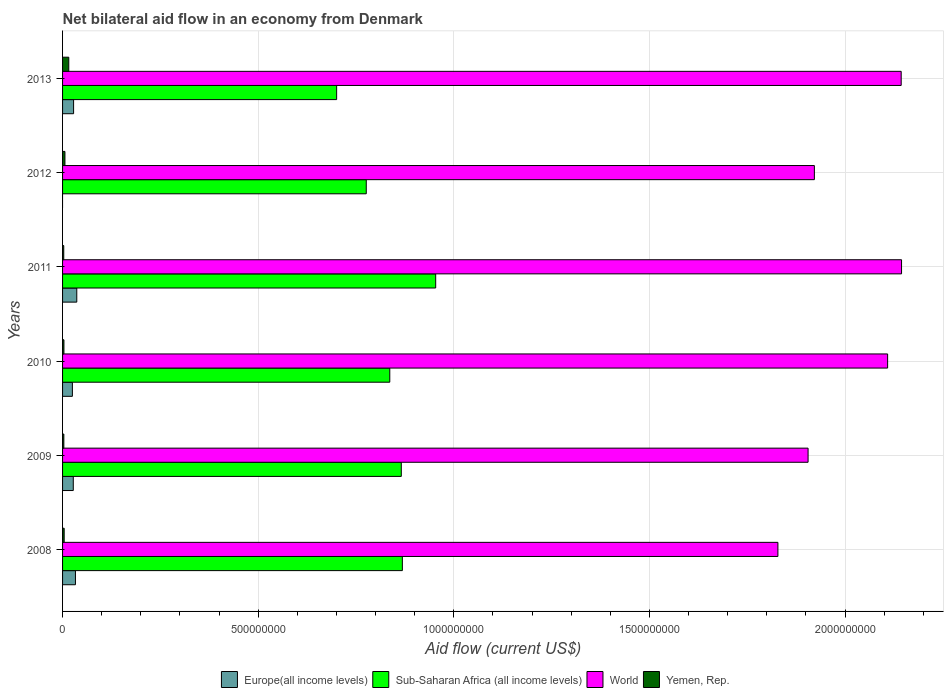How many groups of bars are there?
Keep it short and to the point. 6. Are the number of bars on each tick of the Y-axis equal?
Offer a very short reply. No. How many bars are there on the 5th tick from the bottom?
Make the answer very short. 3. What is the net bilateral aid flow in World in 2013?
Provide a short and direct response. 2.14e+09. Across all years, what is the maximum net bilateral aid flow in World?
Offer a very short reply. 2.14e+09. Across all years, what is the minimum net bilateral aid flow in Yemen, Rep.?
Make the answer very short. 3.02e+06. In which year was the net bilateral aid flow in Europe(all income levels) maximum?
Provide a succinct answer. 2011. What is the total net bilateral aid flow in Yemen, Rep. in the graph?
Your answer should be very brief. 3.58e+07. What is the difference between the net bilateral aid flow in Yemen, Rep. in 2010 and that in 2013?
Give a very brief answer. -1.24e+07. What is the difference between the net bilateral aid flow in World in 2009 and the net bilateral aid flow in Yemen, Rep. in 2011?
Offer a very short reply. 1.90e+09. What is the average net bilateral aid flow in World per year?
Offer a very short reply. 2.01e+09. In the year 2010, what is the difference between the net bilateral aid flow in Sub-Saharan Africa (all income levels) and net bilateral aid flow in Europe(all income levels)?
Offer a very short reply. 8.11e+08. What is the ratio of the net bilateral aid flow in World in 2009 to that in 2013?
Make the answer very short. 0.89. What is the difference between the highest and the second highest net bilateral aid flow in Sub-Saharan Africa (all income levels)?
Your answer should be very brief. 8.52e+07. What is the difference between the highest and the lowest net bilateral aid flow in Europe(all income levels)?
Your answer should be very brief. 3.63e+07. Is it the case that in every year, the sum of the net bilateral aid flow in World and net bilateral aid flow in Europe(all income levels) is greater than the sum of net bilateral aid flow in Sub-Saharan Africa (all income levels) and net bilateral aid flow in Yemen, Rep.?
Keep it short and to the point. Yes. How many bars are there?
Provide a short and direct response. 23. Are all the bars in the graph horizontal?
Offer a very short reply. Yes. How many years are there in the graph?
Your answer should be compact. 6. What is the difference between two consecutive major ticks on the X-axis?
Offer a very short reply. 5.00e+08. Are the values on the major ticks of X-axis written in scientific E-notation?
Offer a terse response. No. Where does the legend appear in the graph?
Offer a very short reply. Bottom center. What is the title of the graph?
Keep it short and to the point. Net bilateral aid flow in an economy from Denmark. Does "Jamaica" appear as one of the legend labels in the graph?
Your response must be concise. No. What is the Aid flow (current US$) of Europe(all income levels) in 2008?
Make the answer very short. 3.29e+07. What is the Aid flow (current US$) in Sub-Saharan Africa (all income levels) in 2008?
Offer a terse response. 8.68e+08. What is the Aid flow (current US$) in World in 2008?
Provide a short and direct response. 1.83e+09. What is the Aid flow (current US$) of Yemen, Rep. in 2008?
Give a very brief answer. 4.12e+06. What is the Aid flow (current US$) of Europe(all income levels) in 2009?
Ensure brevity in your answer.  2.74e+07. What is the Aid flow (current US$) of Sub-Saharan Africa (all income levels) in 2009?
Your response must be concise. 8.66e+08. What is the Aid flow (current US$) in World in 2009?
Your response must be concise. 1.91e+09. What is the Aid flow (current US$) of Yemen, Rep. in 2009?
Ensure brevity in your answer.  3.26e+06. What is the Aid flow (current US$) in Europe(all income levels) in 2010?
Your answer should be compact. 2.51e+07. What is the Aid flow (current US$) in Sub-Saharan Africa (all income levels) in 2010?
Your answer should be very brief. 8.36e+08. What is the Aid flow (current US$) of World in 2010?
Your response must be concise. 2.11e+09. What is the Aid flow (current US$) of Yemen, Rep. in 2010?
Offer a very short reply. 3.49e+06. What is the Aid flow (current US$) of Europe(all income levels) in 2011?
Make the answer very short. 3.63e+07. What is the Aid flow (current US$) in Sub-Saharan Africa (all income levels) in 2011?
Provide a succinct answer. 9.54e+08. What is the Aid flow (current US$) in World in 2011?
Give a very brief answer. 2.14e+09. What is the Aid flow (current US$) in Yemen, Rep. in 2011?
Ensure brevity in your answer.  3.02e+06. What is the Aid flow (current US$) of Sub-Saharan Africa (all income levels) in 2012?
Give a very brief answer. 7.76e+08. What is the Aid flow (current US$) of World in 2012?
Offer a very short reply. 1.92e+09. What is the Aid flow (current US$) in Yemen, Rep. in 2012?
Your response must be concise. 6.05e+06. What is the Aid flow (current US$) of Europe(all income levels) in 2013?
Provide a short and direct response. 2.82e+07. What is the Aid flow (current US$) of Sub-Saharan Africa (all income levels) in 2013?
Make the answer very short. 7.01e+08. What is the Aid flow (current US$) of World in 2013?
Give a very brief answer. 2.14e+09. What is the Aid flow (current US$) in Yemen, Rep. in 2013?
Keep it short and to the point. 1.59e+07. Across all years, what is the maximum Aid flow (current US$) of Europe(all income levels)?
Ensure brevity in your answer.  3.63e+07. Across all years, what is the maximum Aid flow (current US$) of Sub-Saharan Africa (all income levels)?
Ensure brevity in your answer.  9.54e+08. Across all years, what is the maximum Aid flow (current US$) in World?
Your response must be concise. 2.14e+09. Across all years, what is the maximum Aid flow (current US$) of Yemen, Rep.?
Your response must be concise. 1.59e+07. Across all years, what is the minimum Aid flow (current US$) in Europe(all income levels)?
Provide a succinct answer. 0. Across all years, what is the minimum Aid flow (current US$) in Sub-Saharan Africa (all income levels)?
Your answer should be compact. 7.01e+08. Across all years, what is the minimum Aid flow (current US$) of World?
Provide a succinct answer. 1.83e+09. Across all years, what is the minimum Aid flow (current US$) in Yemen, Rep.?
Provide a short and direct response. 3.02e+06. What is the total Aid flow (current US$) in Europe(all income levels) in the graph?
Your answer should be very brief. 1.50e+08. What is the total Aid flow (current US$) in Sub-Saharan Africa (all income levels) in the graph?
Provide a short and direct response. 5.00e+09. What is the total Aid flow (current US$) in World in the graph?
Give a very brief answer. 1.21e+1. What is the total Aid flow (current US$) of Yemen, Rep. in the graph?
Offer a terse response. 3.58e+07. What is the difference between the Aid flow (current US$) of Europe(all income levels) in 2008 and that in 2009?
Provide a short and direct response. 5.56e+06. What is the difference between the Aid flow (current US$) of Sub-Saharan Africa (all income levels) in 2008 and that in 2009?
Give a very brief answer. 2.74e+06. What is the difference between the Aid flow (current US$) of World in 2008 and that in 2009?
Your answer should be compact. -7.71e+07. What is the difference between the Aid flow (current US$) of Yemen, Rep. in 2008 and that in 2009?
Give a very brief answer. 8.60e+05. What is the difference between the Aid flow (current US$) of Europe(all income levels) in 2008 and that in 2010?
Keep it short and to the point. 7.83e+06. What is the difference between the Aid flow (current US$) of Sub-Saharan Africa (all income levels) in 2008 and that in 2010?
Provide a short and direct response. 3.21e+07. What is the difference between the Aid flow (current US$) in World in 2008 and that in 2010?
Provide a short and direct response. -2.80e+08. What is the difference between the Aid flow (current US$) in Yemen, Rep. in 2008 and that in 2010?
Ensure brevity in your answer.  6.30e+05. What is the difference between the Aid flow (current US$) of Europe(all income levels) in 2008 and that in 2011?
Offer a very short reply. -3.41e+06. What is the difference between the Aid flow (current US$) of Sub-Saharan Africa (all income levels) in 2008 and that in 2011?
Offer a very short reply. -8.52e+07. What is the difference between the Aid flow (current US$) of World in 2008 and that in 2011?
Your answer should be compact. -3.16e+08. What is the difference between the Aid flow (current US$) of Yemen, Rep. in 2008 and that in 2011?
Provide a succinct answer. 1.10e+06. What is the difference between the Aid flow (current US$) of Sub-Saharan Africa (all income levels) in 2008 and that in 2012?
Give a very brief answer. 9.23e+07. What is the difference between the Aid flow (current US$) of World in 2008 and that in 2012?
Your response must be concise. -9.32e+07. What is the difference between the Aid flow (current US$) of Yemen, Rep. in 2008 and that in 2012?
Your answer should be compact. -1.93e+06. What is the difference between the Aid flow (current US$) in Europe(all income levels) in 2008 and that in 2013?
Make the answer very short. 4.76e+06. What is the difference between the Aid flow (current US$) in Sub-Saharan Africa (all income levels) in 2008 and that in 2013?
Provide a short and direct response. 1.68e+08. What is the difference between the Aid flow (current US$) of World in 2008 and that in 2013?
Ensure brevity in your answer.  -3.15e+08. What is the difference between the Aid flow (current US$) in Yemen, Rep. in 2008 and that in 2013?
Make the answer very short. -1.18e+07. What is the difference between the Aid flow (current US$) of Europe(all income levels) in 2009 and that in 2010?
Your response must be concise. 2.27e+06. What is the difference between the Aid flow (current US$) in Sub-Saharan Africa (all income levels) in 2009 and that in 2010?
Provide a succinct answer. 2.94e+07. What is the difference between the Aid flow (current US$) of World in 2009 and that in 2010?
Ensure brevity in your answer.  -2.03e+08. What is the difference between the Aid flow (current US$) in Europe(all income levels) in 2009 and that in 2011?
Provide a short and direct response. -8.97e+06. What is the difference between the Aid flow (current US$) of Sub-Saharan Africa (all income levels) in 2009 and that in 2011?
Your answer should be very brief. -8.79e+07. What is the difference between the Aid flow (current US$) in World in 2009 and that in 2011?
Give a very brief answer. -2.39e+08. What is the difference between the Aid flow (current US$) in Yemen, Rep. in 2009 and that in 2011?
Offer a terse response. 2.40e+05. What is the difference between the Aid flow (current US$) of Sub-Saharan Africa (all income levels) in 2009 and that in 2012?
Offer a terse response. 8.95e+07. What is the difference between the Aid flow (current US$) of World in 2009 and that in 2012?
Ensure brevity in your answer.  -1.61e+07. What is the difference between the Aid flow (current US$) in Yemen, Rep. in 2009 and that in 2012?
Ensure brevity in your answer.  -2.79e+06. What is the difference between the Aid flow (current US$) of Europe(all income levels) in 2009 and that in 2013?
Your response must be concise. -8.00e+05. What is the difference between the Aid flow (current US$) of Sub-Saharan Africa (all income levels) in 2009 and that in 2013?
Your response must be concise. 1.65e+08. What is the difference between the Aid flow (current US$) in World in 2009 and that in 2013?
Your answer should be compact. -2.38e+08. What is the difference between the Aid flow (current US$) of Yemen, Rep. in 2009 and that in 2013?
Offer a very short reply. -1.26e+07. What is the difference between the Aid flow (current US$) of Europe(all income levels) in 2010 and that in 2011?
Your answer should be very brief. -1.12e+07. What is the difference between the Aid flow (current US$) in Sub-Saharan Africa (all income levels) in 2010 and that in 2011?
Ensure brevity in your answer.  -1.17e+08. What is the difference between the Aid flow (current US$) of World in 2010 and that in 2011?
Your answer should be very brief. -3.56e+07. What is the difference between the Aid flow (current US$) in Sub-Saharan Africa (all income levels) in 2010 and that in 2012?
Offer a very short reply. 6.01e+07. What is the difference between the Aid flow (current US$) of World in 2010 and that in 2012?
Offer a very short reply. 1.87e+08. What is the difference between the Aid flow (current US$) in Yemen, Rep. in 2010 and that in 2012?
Offer a very short reply. -2.56e+06. What is the difference between the Aid flow (current US$) of Europe(all income levels) in 2010 and that in 2013?
Ensure brevity in your answer.  -3.07e+06. What is the difference between the Aid flow (current US$) in Sub-Saharan Africa (all income levels) in 2010 and that in 2013?
Make the answer very short. 1.36e+08. What is the difference between the Aid flow (current US$) of World in 2010 and that in 2013?
Your response must be concise. -3.47e+07. What is the difference between the Aid flow (current US$) in Yemen, Rep. in 2010 and that in 2013?
Offer a terse response. -1.24e+07. What is the difference between the Aid flow (current US$) in Sub-Saharan Africa (all income levels) in 2011 and that in 2012?
Ensure brevity in your answer.  1.77e+08. What is the difference between the Aid flow (current US$) of World in 2011 and that in 2012?
Give a very brief answer. 2.23e+08. What is the difference between the Aid flow (current US$) of Yemen, Rep. in 2011 and that in 2012?
Your answer should be compact. -3.03e+06. What is the difference between the Aid flow (current US$) of Europe(all income levels) in 2011 and that in 2013?
Ensure brevity in your answer.  8.17e+06. What is the difference between the Aid flow (current US$) of Sub-Saharan Africa (all income levels) in 2011 and that in 2013?
Offer a very short reply. 2.53e+08. What is the difference between the Aid flow (current US$) of World in 2011 and that in 2013?
Make the answer very short. 8.90e+05. What is the difference between the Aid flow (current US$) in Yemen, Rep. in 2011 and that in 2013?
Keep it short and to the point. -1.29e+07. What is the difference between the Aid flow (current US$) in Sub-Saharan Africa (all income levels) in 2012 and that in 2013?
Make the answer very short. 7.57e+07. What is the difference between the Aid flow (current US$) of World in 2012 and that in 2013?
Your answer should be compact. -2.22e+08. What is the difference between the Aid flow (current US$) in Yemen, Rep. in 2012 and that in 2013?
Keep it short and to the point. -9.83e+06. What is the difference between the Aid flow (current US$) of Europe(all income levels) in 2008 and the Aid flow (current US$) of Sub-Saharan Africa (all income levels) in 2009?
Your response must be concise. -8.33e+08. What is the difference between the Aid flow (current US$) of Europe(all income levels) in 2008 and the Aid flow (current US$) of World in 2009?
Provide a short and direct response. -1.87e+09. What is the difference between the Aid flow (current US$) of Europe(all income levels) in 2008 and the Aid flow (current US$) of Yemen, Rep. in 2009?
Provide a succinct answer. 2.97e+07. What is the difference between the Aid flow (current US$) in Sub-Saharan Africa (all income levels) in 2008 and the Aid flow (current US$) in World in 2009?
Your response must be concise. -1.04e+09. What is the difference between the Aid flow (current US$) of Sub-Saharan Africa (all income levels) in 2008 and the Aid flow (current US$) of Yemen, Rep. in 2009?
Your answer should be compact. 8.65e+08. What is the difference between the Aid flow (current US$) in World in 2008 and the Aid flow (current US$) in Yemen, Rep. in 2009?
Your answer should be very brief. 1.83e+09. What is the difference between the Aid flow (current US$) in Europe(all income levels) in 2008 and the Aid flow (current US$) in Sub-Saharan Africa (all income levels) in 2010?
Offer a very short reply. -8.03e+08. What is the difference between the Aid flow (current US$) of Europe(all income levels) in 2008 and the Aid flow (current US$) of World in 2010?
Keep it short and to the point. -2.08e+09. What is the difference between the Aid flow (current US$) of Europe(all income levels) in 2008 and the Aid flow (current US$) of Yemen, Rep. in 2010?
Provide a succinct answer. 2.94e+07. What is the difference between the Aid flow (current US$) of Sub-Saharan Africa (all income levels) in 2008 and the Aid flow (current US$) of World in 2010?
Keep it short and to the point. -1.24e+09. What is the difference between the Aid flow (current US$) of Sub-Saharan Africa (all income levels) in 2008 and the Aid flow (current US$) of Yemen, Rep. in 2010?
Offer a terse response. 8.65e+08. What is the difference between the Aid flow (current US$) in World in 2008 and the Aid flow (current US$) in Yemen, Rep. in 2010?
Offer a terse response. 1.82e+09. What is the difference between the Aid flow (current US$) in Europe(all income levels) in 2008 and the Aid flow (current US$) in Sub-Saharan Africa (all income levels) in 2011?
Keep it short and to the point. -9.21e+08. What is the difference between the Aid flow (current US$) in Europe(all income levels) in 2008 and the Aid flow (current US$) in World in 2011?
Provide a succinct answer. -2.11e+09. What is the difference between the Aid flow (current US$) of Europe(all income levels) in 2008 and the Aid flow (current US$) of Yemen, Rep. in 2011?
Your response must be concise. 2.99e+07. What is the difference between the Aid flow (current US$) in Sub-Saharan Africa (all income levels) in 2008 and the Aid flow (current US$) in World in 2011?
Provide a succinct answer. -1.28e+09. What is the difference between the Aid flow (current US$) in Sub-Saharan Africa (all income levels) in 2008 and the Aid flow (current US$) in Yemen, Rep. in 2011?
Offer a very short reply. 8.65e+08. What is the difference between the Aid flow (current US$) in World in 2008 and the Aid flow (current US$) in Yemen, Rep. in 2011?
Give a very brief answer. 1.83e+09. What is the difference between the Aid flow (current US$) in Europe(all income levels) in 2008 and the Aid flow (current US$) in Sub-Saharan Africa (all income levels) in 2012?
Give a very brief answer. -7.43e+08. What is the difference between the Aid flow (current US$) of Europe(all income levels) in 2008 and the Aid flow (current US$) of World in 2012?
Offer a terse response. -1.89e+09. What is the difference between the Aid flow (current US$) of Europe(all income levels) in 2008 and the Aid flow (current US$) of Yemen, Rep. in 2012?
Offer a very short reply. 2.69e+07. What is the difference between the Aid flow (current US$) of Sub-Saharan Africa (all income levels) in 2008 and the Aid flow (current US$) of World in 2012?
Your answer should be very brief. -1.05e+09. What is the difference between the Aid flow (current US$) in Sub-Saharan Africa (all income levels) in 2008 and the Aid flow (current US$) in Yemen, Rep. in 2012?
Make the answer very short. 8.62e+08. What is the difference between the Aid flow (current US$) of World in 2008 and the Aid flow (current US$) of Yemen, Rep. in 2012?
Offer a very short reply. 1.82e+09. What is the difference between the Aid flow (current US$) in Europe(all income levels) in 2008 and the Aid flow (current US$) in Sub-Saharan Africa (all income levels) in 2013?
Your response must be concise. -6.68e+08. What is the difference between the Aid flow (current US$) of Europe(all income levels) in 2008 and the Aid flow (current US$) of World in 2013?
Your response must be concise. -2.11e+09. What is the difference between the Aid flow (current US$) in Europe(all income levels) in 2008 and the Aid flow (current US$) in Yemen, Rep. in 2013?
Make the answer very short. 1.70e+07. What is the difference between the Aid flow (current US$) in Sub-Saharan Africa (all income levels) in 2008 and the Aid flow (current US$) in World in 2013?
Provide a short and direct response. -1.27e+09. What is the difference between the Aid flow (current US$) of Sub-Saharan Africa (all income levels) in 2008 and the Aid flow (current US$) of Yemen, Rep. in 2013?
Your response must be concise. 8.53e+08. What is the difference between the Aid flow (current US$) of World in 2008 and the Aid flow (current US$) of Yemen, Rep. in 2013?
Provide a short and direct response. 1.81e+09. What is the difference between the Aid flow (current US$) in Europe(all income levels) in 2009 and the Aid flow (current US$) in Sub-Saharan Africa (all income levels) in 2010?
Offer a very short reply. -8.09e+08. What is the difference between the Aid flow (current US$) in Europe(all income levels) in 2009 and the Aid flow (current US$) in World in 2010?
Your response must be concise. -2.08e+09. What is the difference between the Aid flow (current US$) of Europe(all income levels) in 2009 and the Aid flow (current US$) of Yemen, Rep. in 2010?
Your answer should be very brief. 2.39e+07. What is the difference between the Aid flow (current US$) of Sub-Saharan Africa (all income levels) in 2009 and the Aid flow (current US$) of World in 2010?
Your answer should be compact. -1.24e+09. What is the difference between the Aid flow (current US$) in Sub-Saharan Africa (all income levels) in 2009 and the Aid flow (current US$) in Yemen, Rep. in 2010?
Provide a short and direct response. 8.62e+08. What is the difference between the Aid flow (current US$) of World in 2009 and the Aid flow (current US$) of Yemen, Rep. in 2010?
Ensure brevity in your answer.  1.90e+09. What is the difference between the Aid flow (current US$) in Europe(all income levels) in 2009 and the Aid flow (current US$) in Sub-Saharan Africa (all income levels) in 2011?
Ensure brevity in your answer.  -9.26e+08. What is the difference between the Aid flow (current US$) of Europe(all income levels) in 2009 and the Aid flow (current US$) of World in 2011?
Ensure brevity in your answer.  -2.12e+09. What is the difference between the Aid flow (current US$) of Europe(all income levels) in 2009 and the Aid flow (current US$) of Yemen, Rep. in 2011?
Your answer should be very brief. 2.44e+07. What is the difference between the Aid flow (current US$) in Sub-Saharan Africa (all income levels) in 2009 and the Aid flow (current US$) in World in 2011?
Keep it short and to the point. -1.28e+09. What is the difference between the Aid flow (current US$) in Sub-Saharan Africa (all income levels) in 2009 and the Aid flow (current US$) in Yemen, Rep. in 2011?
Your response must be concise. 8.63e+08. What is the difference between the Aid flow (current US$) in World in 2009 and the Aid flow (current US$) in Yemen, Rep. in 2011?
Provide a short and direct response. 1.90e+09. What is the difference between the Aid flow (current US$) of Europe(all income levels) in 2009 and the Aid flow (current US$) of Sub-Saharan Africa (all income levels) in 2012?
Your answer should be compact. -7.49e+08. What is the difference between the Aid flow (current US$) of Europe(all income levels) in 2009 and the Aid flow (current US$) of World in 2012?
Ensure brevity in your answer.  -1.89e+09. What is the difference between the Aid flow (current US$) of Europe(all income levels) in 2009 and the Aid flow (current US$) of Yemen, Rep. in 2012?
Your answer should be very brief. 2.13e+07. What is the difference between the Aid flow (current US$) in Sub-Saharan Africa (all income levels) in 2009 and the Aid flow (current US$) in World in 2012?
Ensure brevity in your answer.  -1.06e+09. What is the difference between the Aid flow (current US$) of Sub-Saharan Africa (all income levels) in 2009 and the Aid flow (current US$) of Yemen, Rep. in 2012?
Offer a very short reply. 8.60e+08. What is the difference between the Aid flow (current US$) of World in 2009 and the Aid flow (current US$) of Yemen, Rep. in 2012?
Ensure brevity in your answer.  1.90e+09. What is the difference between the Aid flow (current US$) in Europe(all income levels) in 2009 and the Aid flow (current US$) in Sub-Saharan Africa (all income levels) in 2013?
Offer a very short reply. -6.73e+08. What is the difference between the Aid flow (current US$) of Europe(all income levels) in 2009 and the Aid flow (current US$) of World in 2013?
Make the answer very short. -2.12e+09. What is the difference between the Aid flow (current US$) of Europe(all income levels) in 2009 and the Aid flow (current US$) of Yemen, Rep. in 2013?
Offer a very short reply. 1.15e+07. What is the difference between the Aid flow (current US$) of Sub-Saharan Africa (all income levels) in 2009 and the Aid flow (current US$) of World in 2013?
Offer a terse response. -1.28e+09. What is the difference between the Aid flow (current US$) of Sub-Saharan Africa (all income levels) in 2009 and the Aid flow (current US$) of Yemen, Rep. in 2013?
Your answer should be compact. 8.50e+08. What is the difference between the Aid flow (current US$) in World in 2009 and the Aid flow (current US$) in Yemen, Rep. in 2013?
Offer a very short reply. 1.89e+09. What is the difference between the Aid flow (current US$) of Europe(all income levels) in 2010 and the Aid flow (current US$) of Sub-Saharan Africa (all income levels) in 2011?
Your response must be concise. -9.29e+08. What is the difference between the Aid flow (current US$) of Europe(all income levels) in 2010 and the Aid flow (current US$) of World in 2011?
Make the answer very short. -2.12e+09. What is the difference between the Aid flow (current US$) in Europe(all income levels) in 2010 and the Aid flow (current US$) in Yemen, Rep. in 2011?
Make the answer very short. 2.21e+07. What is the difference between the Aid flow (current US$) of Sub-Saharan Africa (all income levels) in 2010 and the Aid flow (current US$) of World in 2011?
Your response must be concise. -1.31e+09. What is the difference between the Aid flow (current US$) of Sub-Saharan Africa (all income levels) in 2010 and the Aid flow (current US$) of Yemen, Rep. in 2011?
Give a very brief answer. 8.33e+08. What is the difference between the Aid flow (current US$) of World in 2010 and the Aid flow (current US$) of Yemen, Rep. in 2011?
Your answer should be compact. 2.11e+09. What is the difference between the Aid flow (current US$) in Europe(all income levels) in 2010 and the Aid flow (current US$) in Sub-Saharan Africa (all income levels) in 2012?
Provide a short and direct response. -7.51e+08. What is the difference between the Aid flow (current US$) in Europe(all income levels) in 2010 and the Aid flow (current US$) in World in 2012?
Give a very brief answer. -1.90e+09. What is the difference between the Aid flow (current US$) of Europe(all income levels) in 2010 and the Aid flow (current US$) of Yemen, Rep. in 2012?
Ensure brevity in your answer.  1.90e+07. What is the difference between the Aid flow (current US$) in Sub-Saharan Africa (all income levels) in 2010 and the Aid flow (current US$) in World in 2012?
Ensure brevity in your answer.  -1.09e+09. What is the difference between the Aid flow (current US$) in Sub-Saharan Africa (all income levels) in 2010 and the Aid flow (current US$) in Yemen, Rep. in 2012?
Keep it short and to the point. 8.30e+08. What is the difference between the Aid flow (current US$) in World in 2010 and the Aid flow (current US$) in Yemen, Rep. in 2012?
Make the answer very short. 2.10e+09. What is the difference between the Aid flow (current US$) in Europe(all income levels) in 2010 and the Aid flow (current US$) in Sub-Saharan Africa (all income levels) in 2013?
Ensure brevity in your answer.  -6.75e+08. What is the difference between the Aid flow (current US$) in Europe(all income levels) in 2010 and the Aid flow (current US$) in World in 2013?
Your answer should be compact. -2.12e+09. What is the difference between the Aid flow (current US$) of Europe(all income levels) in 2010 and the Aid flow (current US$) of Yemen, Rep. in 2013?
Keep it short and to the point. 9.22e+06. What is the difference between the Aid flow (current US$) in Sub-Saharan Africa (all income levels) in 2010 and the Aid flow (current US$) in World in 2013?
Ensure brevity in your answer.  -1.31e+09. What is the difference between the Aid flow (current US$) of Sub-Saharan Africa (all income levels) in 2010 and the Aid flow (current US$) of Yemen, Rep. in 2013?
Your answer should be very brief. 8.20e+08. What is the difference between the Aid flow (current US$) in World in 2010 and the Aid flow (current US$) in Yemen, Rep. in 2013?
Make the answer very short. 2.09e+09. What is the difference between the Aid flow (current US$) in Europe(all income levels) in 2011 and the Aid flow (current US$) in Sub-Saharan Africa (all income levels) in 2012?
Give a very brief answer. -7.40e+08. What is the difference between the Aid flow (current US$) of Europe(all income levels) in 2011 and the Aid flow (current US$) of World in 2012?
Provide a succinct answer. -1.89e+09. What is the difference between the Aid flow (current US$) in Europe(all income levels) in 2011 and the Aid flow (current US$) in Yemen, Rep. in 2012?
Your response must be concise. 3.03e+07. What is the difference between the Aid flow (current US$) of Sub-Saharan Africa (all income levels) in 2011 and the Aid flow (current US$) of World in 2012?
Your answer should be very brief. -9.68e+08. What is the difference between the Aid flow (current US$) in Sub-Saharan Africa (all income levels) in 2011 and the Aid flow (current US$) in Yemen, Rep. in 2012?
Keep it short and to the point. 9.48e+08. What is the difference between the Aid flow (current US$) in World in 2011 and the Aid flow (current US$) in Yemen, Rep. in 2012?
Offer a very short reply. 2.14e+09. What is the difference between the Aid flow (current US$) of Europe(all income levels) in 2011 and the Aid flow (current US$) of Sub-Saharan Africa (all income levels) in 2013?
Your answer should be very brief. -6.64e+08. What is the difference between the Aid flow (current US$) in Europe(all income levels) in 2011 and the Aid flow (current US$) in World in 2013?
Provide a short and direct response. -2.11e+09. What is the difference between the Aid flow (current US$) of Europe(all income levels) in 2011 and the Aid flow (current US$) of Yemen, Rep. in 2013?
Give a very brief answer. 2.05e+07. What is the difference between the Aid flow (current US$) of Sub-Saharan Africa (all income levels) in 2011 and the Aid flow (current US$) of World in 2013?
Ensure brevity in your answer.  -1.19e+09. What is the difference between the Aid flow (current US$) of Sub-Saharan Africa (all income levels) in 2011 and the Aid flow (current US$) of Yemen, Rep. in 2013?
Your response must be concise. 9.38e+08. What is the difference between the Aid flow (current US$) in World in 2011 and the Aid flow (current US$) in Yemen, Rep. in 2013?
Offer a terse response. 2.13e+09. What is the difference between the Aid flow (current US$) in Sub-Saharan Africa (all income levels) in 2012 and the Aid flow (current US$) in World in 2013?
Your answer should be very brief. -1.37e+09. What is the difference between the Aid flow (current US$) of Sub-Saharan Africa (all income levels) in 2012 and the Aid flow (current US$) of Yemen, Rep. in 2013?
Offer a terse response. 7.60e+08. What is the difference between the Aid flow (current US$) in World in 2012 and the Aid flow (current US$) in Yemen, Rep. in 2013?
Keep it short and to the point. 1.91e+09. What is the average Aid flow (current US$) of Europe(all income levels) per year?
Your answer should be compact. 2.50e+07. What is the average Aid flow (current US$) of Sub-Saharan Africa (all income levels) per year?
Your response must be concise. 8.33e+08. What is the average Aid flow (current US$) in World per year?
Ensure brevity in your answer.  2.01e+09. What is the average Aid flow (current US$) in Yemen, Rep. per year?
Give a very brief answer. 5.97e+06. In the year 2008, what is the difference between the Aid flow (current US$) of Europe(all income levels) and Aid flow (current US$) of Sub-Saharan Africa (all income levels)?
Give a very brief answer. -8.36e+08. In the year 2008, what is the difference between the Aid flow (current US$) in Europe(all income levels) and Aid flow (current US$) in World?
Provide a short and direct response. -1.80e+09. In the year 2008, what is the difference between the Aid flow (current US$) in Europe(all income levels) and Aid flow (current US$) in Yemen, Rep.?
Ensure brevity in your answer.  2.88e+07. In the year 2008, what is the difference between the Aid flow (current US$) of Sub-Saharan Africa (all income levels) and Aid flow (current US$) of World?
Provide a succinct answer. -9.60e+08. In the year 2008, what is the difference between the Aid flow (current US$) in Sub-Saharan Africa (all income levels) and Aid flow (current US$) in Yemen, Rep.?
Make the answer very short. 8.64e+08. In the year 2008, what is the difference between the Aid flow (current US$) in World and Aid flow (current US$) in Yemen, Rep.?
Offer a very short reply. 1.82e+09. In the year 2009, what is the difference between the Aid flow (current US$) of Europe(all income levels) and Aid flow (current US$) of Sub-Saharan Africa (all income levels)?
Offer a very short reply. -8.38e+08. In the year 2009, what is the difference between the Aid flow (current US$) of Europe(all income levels) and Aid flow (current US$) of World?
Ensure brevity in your answer.  -1.88e+09. In the year 2009, what is the difference between the Aid flow (current US$) of Europe(all income levels) and Aid flow (current US$) of Yemen, Rep.?
Provide a succinct answer. 2.41e+07. In the year 2009, what is the difference between the Aid flow (current US$) in Sub-Saharan Africa (all income levels) and Aid flow (current US$) in World?
Offer a very short reply. -1.04e+09. In the year 2009, what is the difference between the Aid flow (current US$) of Sub-Saharan Africa (all income levels) and Aid flow (current US$) of Yemen, Rep.?
Ensure brevity in your answer.  8.62e+08. In the year 2009, what is the difference between the Aid flow (current US$) in World and Aid flow (current US$) in Yemen, Rep.?
Keep it short and to the point. 1.90e+09. In the year 2010, what is the difference between the Aid flow (current US$) of Europe(all income levels) and Aid flow (current US$) of Sub-Saharan Africa (all income levels)?
Give a very brief answer. -8.11e+08. In the year 2010, what is the difference between the Aid flow (current US$) of Europe(all income levels) and Aid flow (current US$) of World?
Your answer should be compact. -2.08e+09. In the year 2010, what is the difference between the Aid flow (current US$) in Europe(all income levels) and Aid flow (current US$) in Yemen, Rep.?
Ensure brevity in your answer.  2.16e+07. In the year 2010, what is the difference between the Aid flow (current US$) in Sub-Saharan Africa (all income levels) and Aid flow (current US$) in World?
Ensure brevity in your answer.  -1.27e+09. In the year 2010, what is the difference between the Aid flow (current US$) in Sub-Saharan Africa (all income levels) and Aid flow (current US$) in Yemen, Rep.?
Your response must be concise. 8.33e+08. In the year 2010, what is the difference between the Aid flow (current US$) of World and Aid flow (current US$) of Yemen, Rep.?
Make the answer very short. 2.11e+09. In the year 2011, what is the difference between the Aid flow (current US$) in Europe(all income levels) and Aid flow (current US$) in Sub-Saharan Africa (all income levels)?
Offer a terse response. -9.17e+08. In the year 2011, what is the difference between the Aid flow (current US$) of Europe(all income levels) and Aid flow (current US$) of World?
Ensure brevity in your answer.  -2.11e+09. In the year 2011, what is the difference between the Aid flow (current US$) of Europe(all income levels) and Aid flow (current US$) of Yemen, Rep.?
Your answer should be very brief. 3.33e+07. In the year 2011, what is the difference between the Aid flow (current US$) in Sub-Saharan Africa (all income levels) and Aid flow (current US$) in World?
Provide a short and direct response. -1.19e+09. In the year 2011, what is the difference between the Aid flow (current US$) of Sub-Saharan Africa (all income levels) and Aid flow (current US$) of Yemen, Rep.?
Your answer should be very brief. 9.51e+08. In the year 2011, what is the difference between the Aid flow (current US$) of World and Aid flow (current US$) of Yemen, Rep.?
Offer a very short reply. 2.14e+09. In the year 2012, what is the difference between the Aid flow (current US$) of Sub-Saharan Africa (all income levels) and Aid flow (current US$) of World?
Offer a very short reply. -1.15e+09. In the year 2012, what is the difference between the Aid flow (current US$) of Sub-Saharan Africa (all income levels) and Aid flow (current US$) of Yemen, Rep.?
Keep it short and to the point. 7.70e+08. In the year 2012, what is the difference between the Aid flow (current US$) in World and Aid flow (current US$) in Yemen, Rep.?
Your answer should be very brief. 1.92e+09. In the year 2013, what is the difference between the Aid flow (current US$) in Europe(all income levels) and Aid flow (current US$) in Sub-Saharan Africa (all income levels)?
Provide a succinct answer. -6.72e+08. In the year 2013, what is the difference between the Aid flow (current US$) of Europe(all income levels) and Aid flow (current US$) of World?
Your answer should be compact. -2.12e+09. In the year 2013, what is the difference between the Aid flow (current US$) in Europe(all income levels) and Aid flow (current US$) in Yemen, Rep.?
Your answer should be compact. 1.23e+07. In the year 2013, what is the difference between the Aid flow (current US$) of Sub-Saharan Africa (all income levels) and Aid flow (current US$) of World?
Offer a very short reply. -1.44e+09. In the year 2013, what is the difference between the Aid flow (current US$) in Sub-Saharan Africa (all income levels) and Aid flow (current US$) in Yemen, Rep.?
Your answer should be very brief. 6.85e+08. In the year 2013, what is the difference between the Aid flow (current US$) of World and Aid flow (current US$) of Yemen, Rep.?
Give a very brief answer. 2.13e+09. What is the ratio of the Aid flow (current US$) of Europe(all income levels) in 2008 to that in 2009?
Provide a short and direct response. 1.2. What is the ratio of the Aid flow (current US$) in Sub-Saharan Africa (all income levels) in 2008 to that in 2009?
Make the answer very short. 1. What is the ratio of the Aid flow (current US$) of World in 2008 to that in 2009?
Offer a terse response. 0.96. What is the ratio of the Aid flow (current US$) of Yemen, Rep. in 2008 to that in 2009?
Offer a terse response. 1.26. What is the ratio of the Aid flow (current US$) in Europe(all income levels) in 2008 to that in 2010?
Your response must be concise. 1.31. What is the ratio of the Aid flow (current US$) in Sub-Saharan Africa (all income levels) in 2008 to that in 2010?
Offer a very short reply. 1.04. What is the ratio of the Aid flow (current US$) in World in 2008 to that in 2010?
Your answer should be compact. 0.87. What is the ratio of the Aid flow (current US$) of Yemen, Rep. in 2008 to that in 2010?
Provide a succinct answer. 1.18. What is the ratio of the Aid flow (current US$) of Europe(all income levels) in 2008 to that in 2011?
Ensure brevity in your answer.  0.91. What is the ratio of the Aid flow (current US$) of Sub-Saharan Africa (all income levels) in 2008 to that in 2011?
Your answer should be very brief. 0.91. What is the ratio of the Aid flow (current US$) of World in 2008 to that in 2011?
Your response must be concise. 0.85. What is the ratio of the Aid flow (current US$) of Yemen, Rep. in 2008 to that in 2011?
Your answer should be compact. 1.36. What is the ratio of the Aid flow (current US$) of Sub-Saharan Africa (all income levels) in 2008 to that in 2012?
Give a very brief answer. 1.12. What is the ratio of the Aid flow (current US$) of World in 2008 to that in 2012?
Your response must be concise. 0.95. What is the ratio of the Aid flow (current US$) of Yemen, Rep. in 2008 to that in 2012?
Your answer should be compact. 0.68. What is the ratio of the Aid flow (current US$) of Europe(all income levels) in 2008 to that in 2013?
Your answer should be compact. 1.17. What is the ratio of the Aid flow (current US$) in Sub-Saharan Africa (all income levels) in 2008 to that in 2013?
Give a very brief answer. 1.24. What is the ratio of the Aid flow (current US$) in World in 2008 to that in 2013?
Offer a terse response. 0.85. What is the ratio of the Aid flow (current US$) in Yemen, Rep. in 2008 to that in 2013?
Your answer should be very brief. 0.26. What is the ratio of the Aid flow (current US$) in Europe(all income levels) in 2009 to that in 2010?
Offer a terse response. 1.09. What is the ratio of the Aid flow (current US$) of Sub-Saharan Africa (all income levels) in 2009 to that in 2010?
Ensure brevity in your answer.  1.04. What is the ratio of the Aid flow (current US$) in World in 2009 to that in 2010?
Give a very brief answer. 0.9. What is the ratio of the Aid flow (current US$) of Yemen, Rep. in 2009 to that in 2010?
Offer a terse response. 0.93. What is the ratio of the Aid flow (current US$) in Europe(all income levels) in 2009 to that in 2011?
Ensure brevity in your answer.  0.75. What is the ratio of the Aid flow (current US$) in Sub-Saharan Africa (all income levels) in 2009 to that in 2011?
Your response must be concise. 0.91. What is the ratio of the Aid flow (current US$) in World in 2009 to that in 2011?
Ensure brevity in your answer.  0.89. What is the ratio of the Aid flow (current US$) of Yemen, Rep. in 2009 to that in 2011?
Offer a terse response. 1.08. What is the ratio of the Aid flow (current US$) of Sub-Saharan Africa (all income levels) in 2009 to that in 2012?
Make the answer very short. 1.12. What is the ratio of the Aid flow (current US$) of World in 2009 to that in 2012?
Make the answer very short. 0.99. What is the ratio of the Aid flow (current US$) of Yemen, Rep. in 2009 to that in 2012?
Your answer should be compact. 0.54. What is the ratio of the Aid flow (current US$) in Europe(all income levels) in 2009 to that in 2013?
Provide a short and direct response. 0.97. What is the ratio of the Aid flow (current US$) in Sub-Saharan Africa (all income levels) in 2009 to that in 2013?
Your answer should be very brief. 1.24. What is the ratio of the Aid flow (current US$) of World in 2009 to that in 2013?
Your answer should be very brief. 0.89. What is the ratio of the Aid flow (current US$) in Yemen, Rep. in 2009 to that in 2013?
Ensure brevity in your answer.  0.21. What is the ratio of the Aid flow (current US$) in Europe(all income levels) in 2010 to that in 2011?
Keep it short and to the point. 0.69. What is the ratio of the Aid flow (current US$) of Sub-Saharan Africa (all income levels) in 2010 to that in 2011?
Ensure brevity in your answer.  0.88. What is the ratio of the Aid flow (current US$) of World in 2010 to that in 2011?
Your answer should be very brief. 0.98. What is the ratio of the Aid flow (current US$) in Yemen, Rep. in 2010 to that in 2011?
Keep it short and to the point. 1.16. What is the ratio of the Aid flow (current US$) in Sub-Saharan Africa (all income levels) in 2010 to that in 2012?
Offer a very short reply. 1.08. What is the ratio of the Aid flow (current US$) in World in 2010 to that in 2012?
Ensure brevity in your answer.  1.1. What is the ratio of the Aid flow (current US$) of Yemen, Rep. in 2010 to that in 2012?
Your answer should be very brief. 0.58. What is the ratio of the Aid flow (current US$) in Europe(all income levels) in 2010 to that in 2013?
Make the answer very short. 0.89. What is the ratio of the Aid flow (current US$) of Sub-Saharan Africa (all income levels) in 2010 to that in 2013?
Your answer should be compact. 1.19. What is the ratio of the Aid flow (current US$) of World in 2010 to that in 2013?
Your response must be concise. 0.98. What is the ratio of the Aid flow (current US$) in Yemen, Rep. in 2010 to that in 2013?
Your answer should be very brief. 0.22. What is the ratio of the Aid flow (current US$) of Sub-Saharan Africa (all income levels) in 2011 to that in 2012?
Your answer should be very brief. 1.23. What is the ratio of the Aid flow (current US$) in World in 2011 to that in 2012?
Your answer should be compact. 1.12. What is the ratio of the Aid flow (current US$) in Yemen, Rep. in 2011 to that in 2012?
Offer a terse response. 0.5. What is the ratio of the Aid flow (current US$) in Europe(all income levels) in 2011 to that in 2013?
Your answer should be very brief. 1.29. What is the ratio of the Aid flow (current US$) of Sub-Saharan Africa (all income levels) in 2011 to that in 2013?
Keep it short and to the point. 1.36. What is the ratio of the Aid flow (current US$) in World in 2011 to that in 2013?
Provide a short and direct response. 1. What is the ratio of the Aid flow (current US$) of Yemen, Rep. in 2011 to that in 2013?
Your answer should be compact. 0.19. What is the ratio of the Aid flow (current US$) of Sub-Saharan Africa (all income levels) in 2012 to that in 2013?
Offer a very short reply. 1.11. What is the ratio of the Aid flow (current US$) in World in 2012 to that in 2013?
Give a very brief answer. 0.9. What is the ratio of the Aid flow (current US$) of Yemen, Rep. in 2012 to that in 2013?
Give a very brief answer. 0.38. What is the difference between the highest and the second highest Aid flow (current US$) of Europe(all income levels)?
Your response must be concise. 3.41e+06. What is the difference between the highest and the second highest Aid flow (current US$) of Sub-Saharan Africa (all income levels)?
Your answer should be very brief. 8.52e+07. What is the difference between the highest and the second highest Aid flow (current US$) in World?
Provide a succinct answer. 8.90e+05. What is the difference between the highest and the second highest Aid flow (current US$) of Yemen, Rep.?
Make the answer very short. 9.83e+06. What is the difference between the highest and the lowest Aid flow (current US$) in Europe(all income levels)?
Your answer should be very brief. 3.63e+07. What is the difference between the highest and the lowest Aid flow (current US$) of Sub-Saharan Africa (all income levels)?
Your response must be concise. 2.53e+08. What is the difference between the highest and the lowest Aid flow (current US$) of World?
Offer a terse response. 3.16e+08. What is the difference between the highest and the lowest Aid flow (current US$) of Yemen, Rep.?
Your answer should be compact. 1.29e+07. 